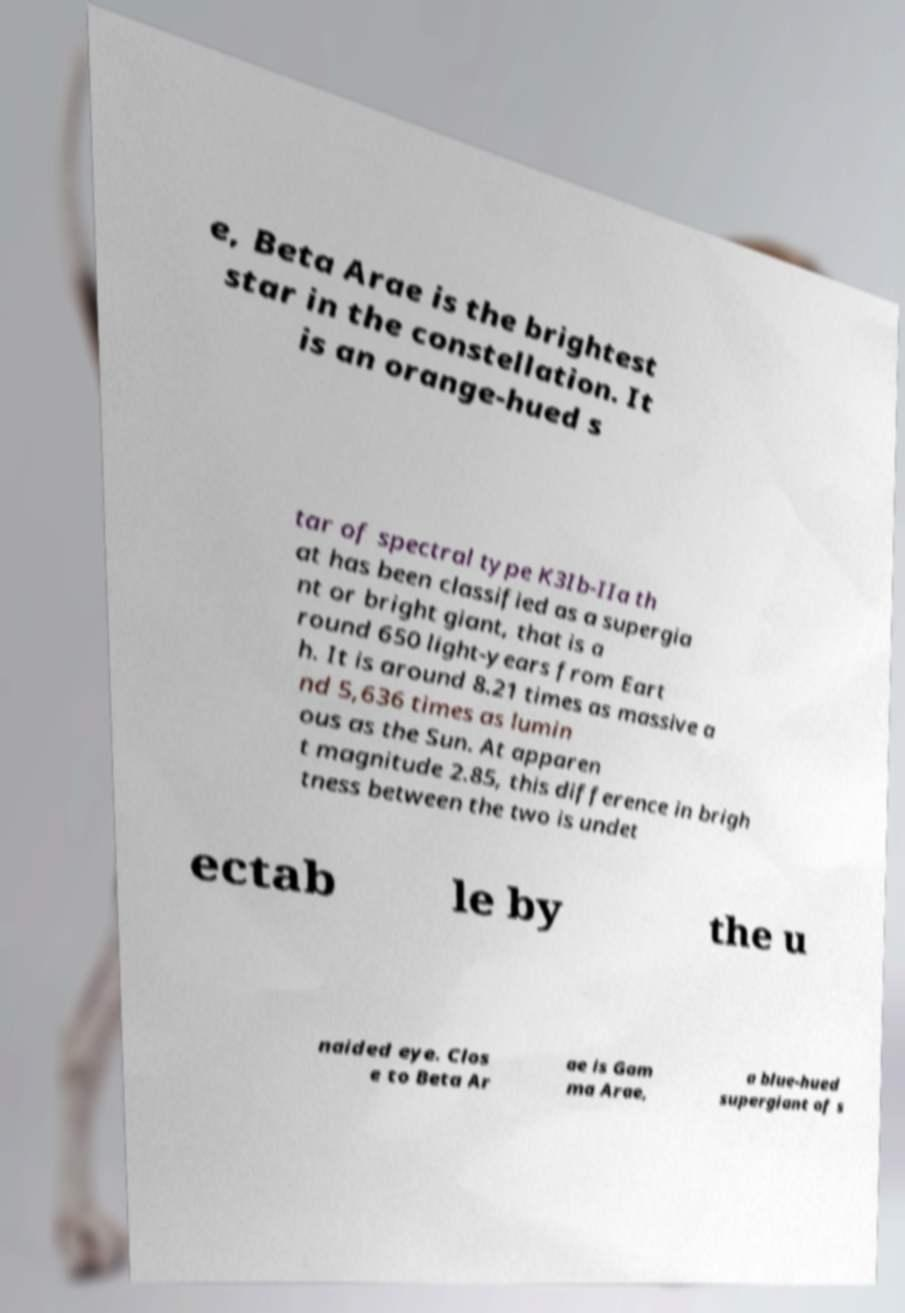Please read and relay the text visible in this image. What does it say? e, Beta Arae is the brightest star in the constellation. It is an orange-hued s tar of spectral type K3Ib-IIa th at has been classified as a supergia nt or bright giant, that is a round 650 light-years from Eart h. It is around 8.21 times as massive a nd 5,636 times as lumin ous as the Sun. At apparen t magnitude 2.85, this difference in brigh tness between the two is undet ectab le by the u naided eye. Clos e to Beta Ar ae is Gam ma Arae, a blue-hued supergiant of s 